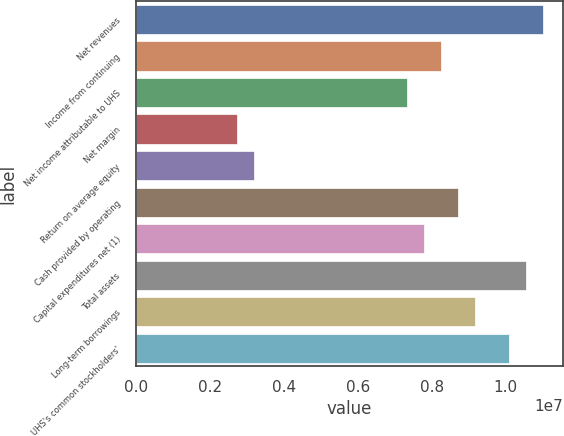Convert chart to OTSL. <chart><loc_0><loc_0><loc_500><loc_500><bar_chart><fcel>Net revenues<fcel>Income from continuing<fcel>Net income attributable to UHS<fcel>Net margin<fcel>Return on average equity<fcel>Cash provided by operating<fcel>Capital expenditures net (1)<fcel>Total assets<fcel>Long-term borrowings<fcel>UHS's common stockholders'<nl><fcel>1.10048e+07<fcel>8.25359e+06<fcel>7.33653e+06<fcel>2.7512e+06<fcel>3.20973e+06<fcel>8.71212e+06<fcel>7.79506e+06<fcel>1.05463e+07<fcel>9.17066e+06<fcel>1.00877e+07<nl></chart> 